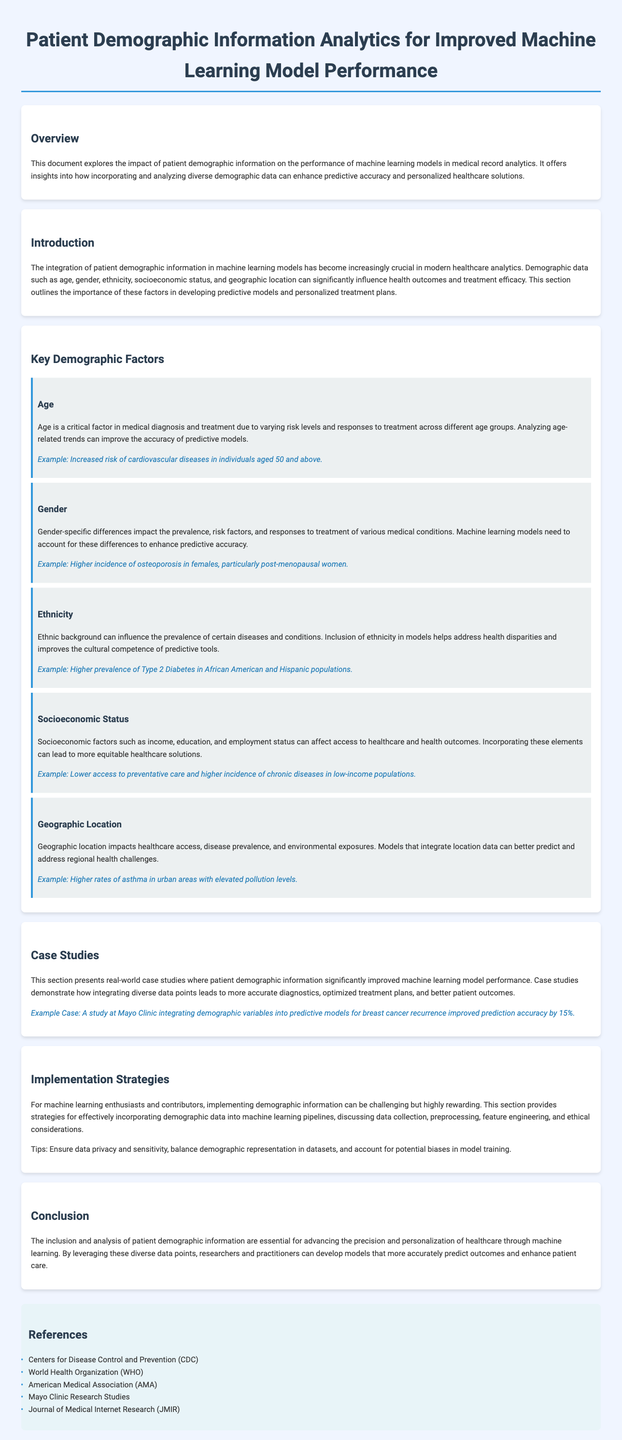what is the title of the document? The title of the document is located in the header section, which provides the main focus of the content.
Answer: Patient Demographic Information Analytics for Improved Machine Learning Model Performance what demographic factor is mentioned first? The first demographic factor mentioned in the document is a key point discussed in the Key Demographic Factors section.
Answer: Age what is one example of a gender-specific difference? The example provided highlights a specific condition that commonly affects one gender more than the other, illustrating its relevance.
Answer: Higher incidence of osteoporosis in females, particularly post-menopausal women how much did the prediction accuracy improve by integrating demographic variables? The improvement in prediction accuracy due to the integration of demographic variables is presented in the Case Studies section.
Answer: 15% what are two implementation strategies mentioned? The strategies discussed pertain to effectively incorporating demographic data into machine learning processes, focusing on multiple aspects.
Answer: Ensure data privacy and sensitivity, balance demographic representation in datasets which organization is listed as a reference? The references section includes notable organizations that contribute to medical research and analytics.
Answer: Centers for Disease Control and Prevention (CDC) what health condition is associated with urban areas in the document? This condition is highlighted as affected by environmental factors prevalent in city environments, as mentioned in the document.
Answer: Higher rates of asthma what is the main conclusion of the document? The conclusion summarizes the overall message regarding the use of demographic information in healthcare analytics.
Answer: The inclusion and analysis of patient demographic information are essential for advancing the precision and personalization of healthcare through machine learning 